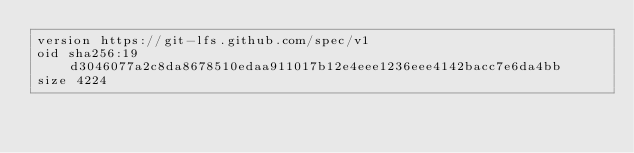Convert code to text. <code><loc_0><loc_0><loc_500><loc_500><_SQL_>version https://git-lfs.github.com/spec/v1
oid sha256:19d3046077a2c8da8678510edaa911017b12e4eee1236eee4142bacc7e6da4bb
size 4224
</code> 